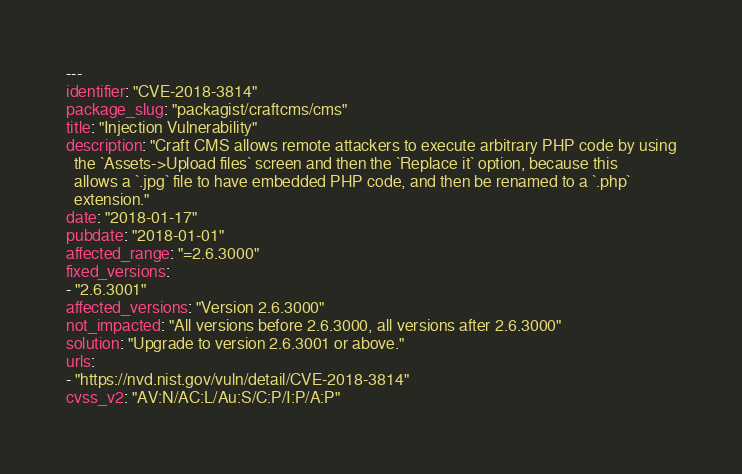<code> <loc_0><loc_0><loc_500><loc_500><_YAML_>---
identifier: "CVE-2018-3814"
package_slug: "packagist/craftcms/cms"
title: "Injection Vulnerability"
description: "Craft CMS allows remote attackers to execute arbitrary PHP code by using
  the `Assets->Upload files` screen and then the `Replace it` option, because this
  allows a `.jpg` file to have embedded PHP code, and then be renamed to a `.php`
  extension."
date: "2018-01-17"
pubdate: "2018-01-01"
affected_range: "=2.6.3000"
fixed_versions:
- "2.6.3001"
affected_versions: "Version 2.6.3000"
not_impacted: "All versions before 2.6.3000, all versions after 2.6.3000"
solution: "Upgrade to version 2.6.3001 or above."
urls:
- "https://nvd.nist.gov/vuln/detail/CVE-2018-3814"
cvss_v2: "AV:N/AC:L/Au:S/C:P/I:P/A:P"</code> 